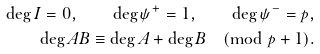Convert formula to latex. <formula><loc_0><loc_0><loc_500><loc_500>\deg I = 0 , \quad \deg \psi ^ { + } = 1 , \quad \deg \psi ^ { - } = p , \\ \deg A B \equiv \deg A + \deg B \pmod { p + 1 } .</formula> 